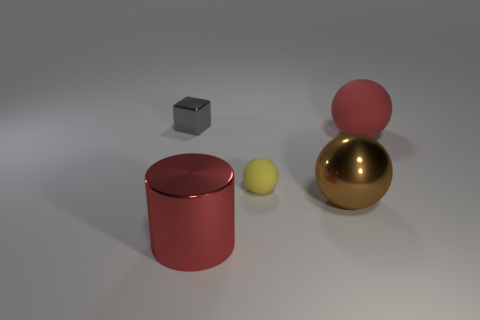Is there anything else that is the same shape as the gray metallic object?
Give a very brief answer. No. What number of matte things have the same color as the large cylinder?
Your answer should be very brief. 1. Are the large sphere that is in front of the red rubber thing and the tiny yellow sphere made of the same material?
Provide a short and direct response. No. What material is the red sphere that is the same size as the brown metallic thing?
Ensure brevity in your answer.  Rubber. There is a big sphere in front of the big red thing behind the big red cylinder; are there any large things in front of it?
Provide a short and direct response. Yes. There is a shiny thing to the left of the red thing that is to the left of the large object that is right of the big brown metallic sphere; what size is it?
Ensure brevity in your answer.  Small. There is a large thing that is behind the tiny object in front of the tiny gray thing; what color is it?
Provide a succinct answer. Red. How many other objects are there of the same color as the cylinder?
Keep it short and to the point. 1. What material is the small thing in front of the red thing that is behind the big brown ball made of?
Provide a short and direct response. Rubber. Are there any small gray matte cylinders?
Your answer should be compact. No. 